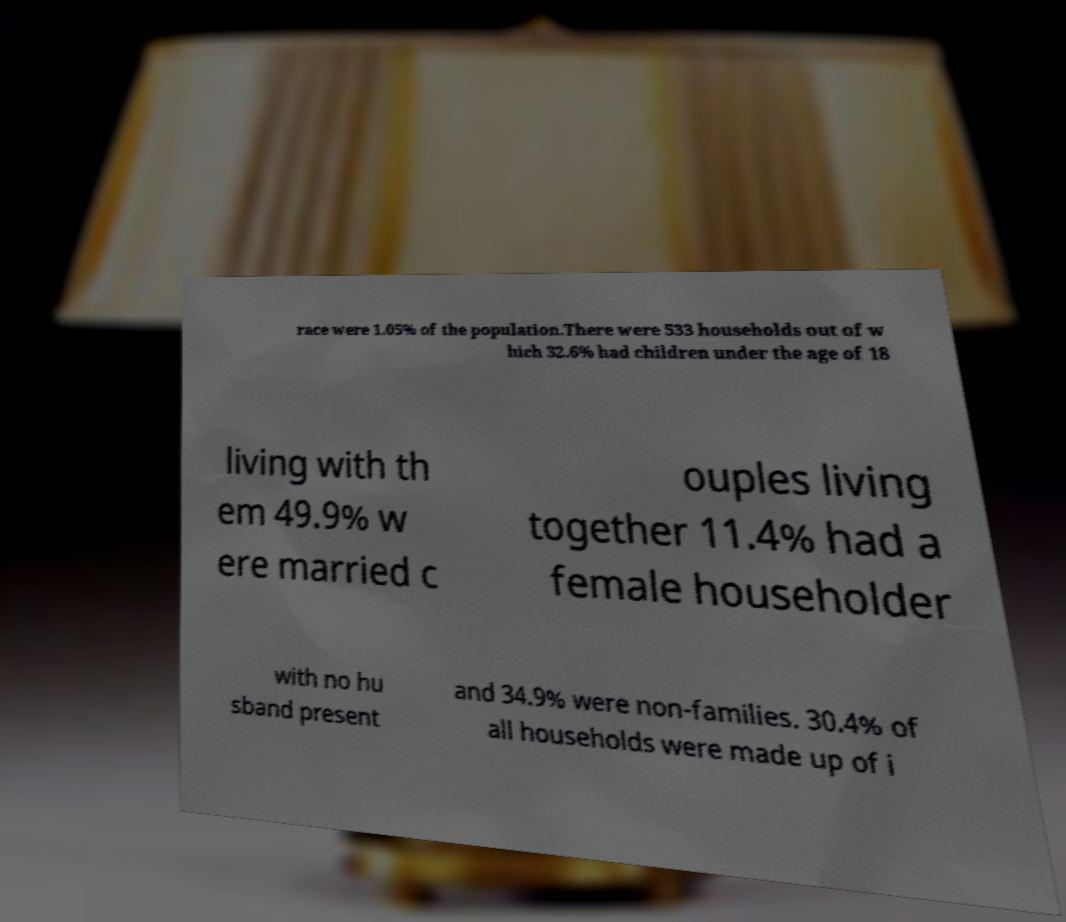I need the written content from this picture converted into text. Can you do that? race were 1.05% of the population.There were 533 households out of w hich 32.6% had children under the age of 18 living with th em 49.9% w ere married c ouples living together 11.4% had a female householder with no hu sband present and 34.9% were non-families. 30.4% of all households were made up of i 